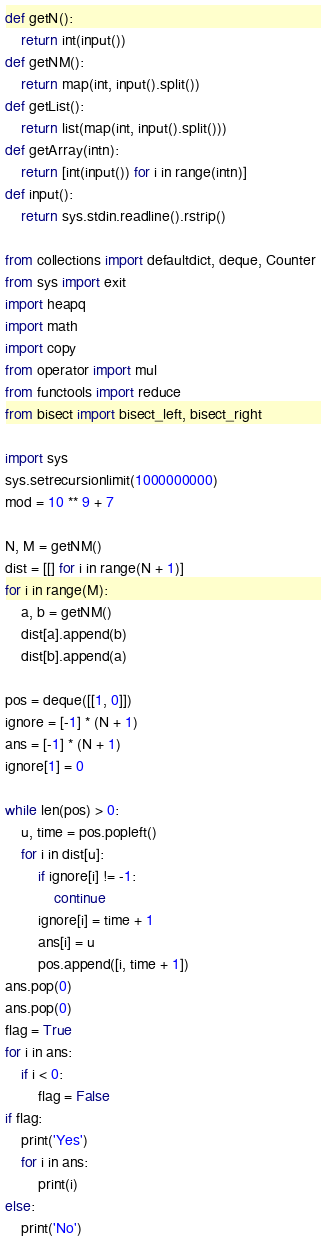Convert code to text. <code><loc_0><loc_0><loc_500><loc_500><_Python_>def getN():
    return int(input())
def getNM():
    return map(int, input().split())
def getList():
    return list(map(int, input().split()))
def getArray(intn):
    return [int(input()) for i in range(intn)]
def input():
    return sys.stdin.readline().rstrip()

from collections import defaultdict, deque, Counter
from sys import exit
import heapq
import math
import copy
from operator import mul
from functools import reduce
from bisect import bisect_left, bisect_right

import sys
sys.setrecursionlimit(1000000000)
mod = 10 ** 9 + 7

N, M = getNM()
dist = [[] for i in range(N + 1)]
for i in range(M):
    a, b = getNM()
    dist[a].append(b)
    dist[b].append(a)

pos = deque([[1, 0]])
ignore = [-1] * (N + 1)
ans = [-1] * (N + 1)
ignore[1] = 0

while len(pos) > 0:
    u, time = pos.popleft()
    for i in dist[u]:
        if ignore[i] != -1:
            continue
        ignore[i] = time + 1
        ans[i] = u
        pos.append([i, time + 1])
ans.pop(0)
ans.pop(0)
flag = True
for i in ans:
    if i < 0:
        flag = False
if flag:
    print('Yes')
    for i in ans:
        print(i)
else:
    print('No')</code> 